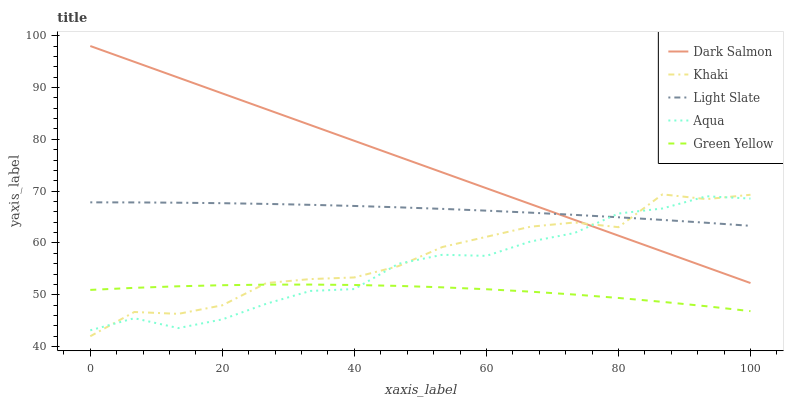Does Green Yellow have the minimum area under the curve?
Answer yes or no. Yes. Does Dark Salmon have the maximum area under the curve?
Answer yes or no. Yes. Does Khaki have the minimum area under the curve?
Answer yes or no. No. Does Khaki have the maximum area under the curve?
Answer yes or no. No. Is Dark Salmon the smoothest?
Answer yes or no. Yes. Is Khaki the roughest?
Answer yes or no. Yes. Is Green Yellow the smoothest?
Answer yes or no. No. Is Green Yellow the roughest?
Answer yes or no. No. Does Green Yellow have the lowest value?
Answer yes or no. No. Does Khaki have the highest value?
Answer yes or no. No. Is Green Yellow less than Light Slate?
Answer yes or no. Yes. Is Light Slate greater than Green Yellow?
Answer yes or no. Yes. Does Green Yellow intersect Light Slate?
Answer yes or no. No. 